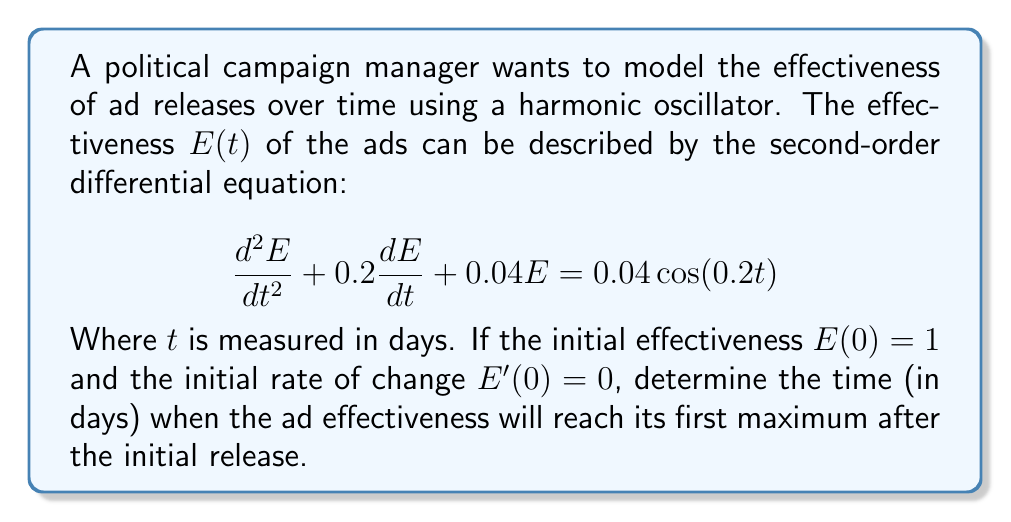Solve this math problem. To solve this problem, we need to follow these steps:

1) First, we recognize this as a forced harmonic oscillator equation with damping. The general solution will be the sum of the complementary solution (homogeneous solution) and the particular solution.

2) The complementary solution has the form:

   $$E_c(t) = e^{-0.1t}(A\cos(0.1t) + B\sin(0.1t))$$

   Where $A$ and $B$ are constants to be determined from initial conditions.

3) The particular solution, due to the forcing term, will have the form:

   $$E_p(t) = C\cos(0.2t) + D\sin(0.2t)$$

   Substituting this into the original equation and solving for $C$ and $D$ gives:
   
   $$E_p(t) = 0.8\cos(0.2t) + 0.2\sin(0.2t)$$

4) The complete solution is:

   $$E(t) = e^{-0.1t}(A\cos(0.1t) + B\sin(0.1t)) + 0.8\cos(0.2t) + 0.2\sin(0.2t)$$

5) Using the initial conditions:
   
   $E(0) = 1$ gives $A + 0.8 = 1$, so $A = 0.2$
   
   $E'(0) = 0$ gives $-0.1A + 0.1B + 0.16 = 0$, so $B = -0.14$

6) Therefore, the full solution is:

   $$E(t) = e^{-0.1t}(0.2\cos(0.1t) - 0.14\sin(0.1t)) + 0.8\cos(0.2t) + 0.2\sin(0.2t)$$

7) To find the maximum, we need to differentiate $E(t)$ and set it to zero. However, this leads to a transcendental equation that's difficult to solve analytically.

8) Instead, we can observe that the exponential term will decay quickly, and the maximum will occur close to where the cosine term in the particular solution reaches its peak.

9) The cosine term $0.8\cos(0.2t)$ will reach its first maximum after $t=0$ when $0.2t = 2\pi$, or $t = 10\pi \approx 31.42$ days.
Answer: The ad effectiveness will reach its first maximum approximately 31.42 days after the initial release. 